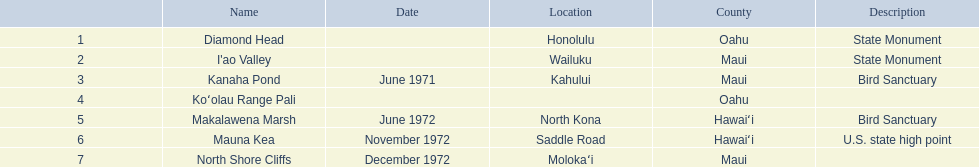What are all the landmark names? Diamond Head, I'ao Valley, Kanaha Pond, Koʻolau Range Pali, Makalawena Marsh, Mauna Kea, North Shore Cliffs. Which county is each landlord in? Oahu, Maui, Maui, Oahu, Hawaiʻi, Hawaiʻi, Maui. Along with mauna kea, which landmark is in hawai'i county? Makalawena Marsh. 